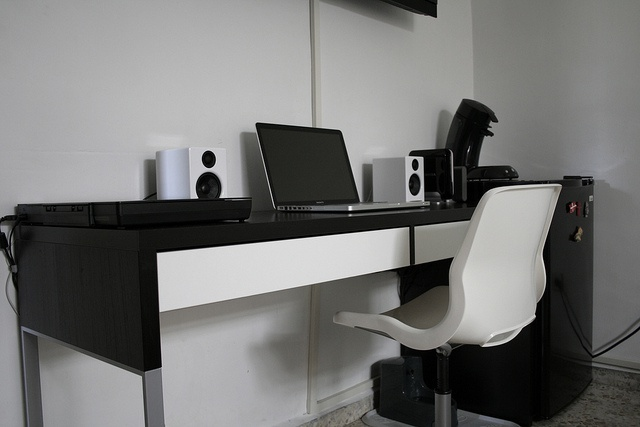Describe the objects in this image and their specific colors. I can see chair in gray, darkgray, lightgray, and black tones, refrigerator in gray, black, maroon, and darkgray tones, and laptop in gray, black, darkgray, and lightgray tones in this image. 